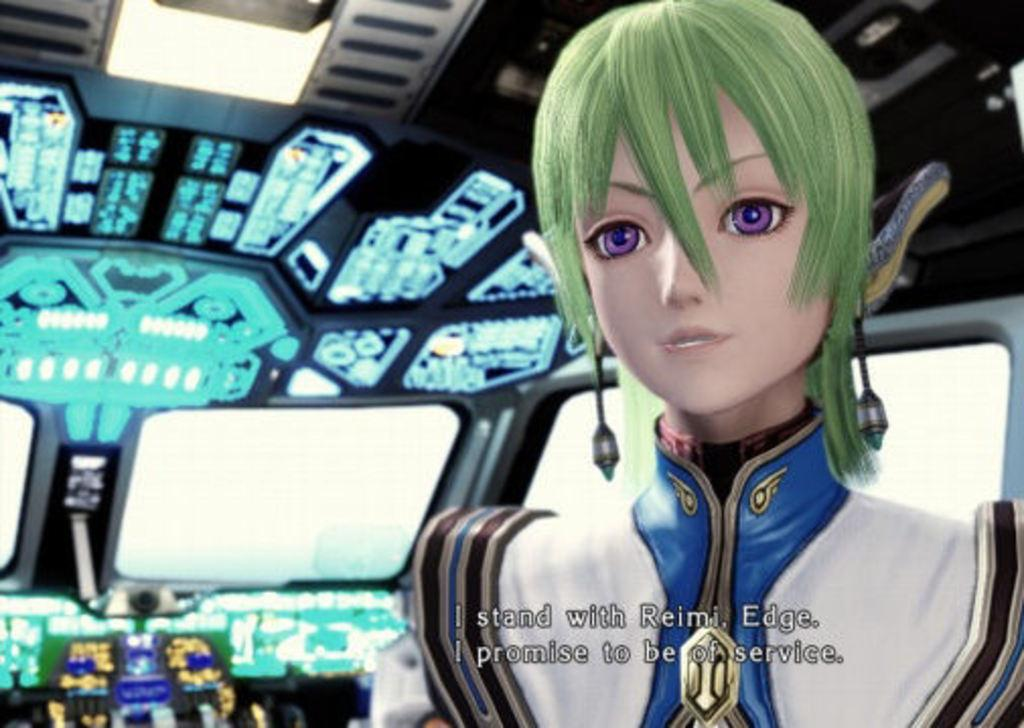<image>
Share a concise interpretation of the image provided. An anime figure with green hair proclaims she stands with Reimi. 